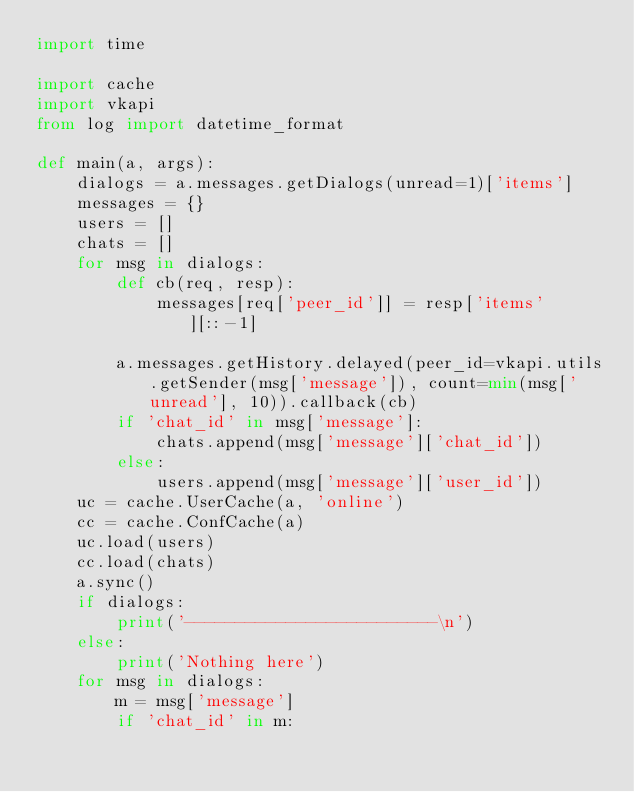<code> <loc_0><loc_0><loc_500><loc_500><_Python_>import time

import cache
import vkapi
from log import datetime_format

def main(a, args):
    dialogs = a.messages.getDialogs(unread=1)['items']
    messages = {}
    users = []
    chats = []
    for msg in dialogs:
        def cb(req, resp):
            messages[req['peer_id']] = resp['items'][::-1]

        a.messages.getHistory.delayed(peer_id=vkapi.utils.getSender(msg['message']), count=min(msg['unread'], 10)).callback(cb)
        if 'chat_id' in msg['message']:
            chats.append(msg['message']['chat_id'])
        else:
            users.append(msg['message']['user_id'])
    uc = cache.UserCache(a, 'online')
    cc = cache.ConfCache(a)
    uc.load(users)
    cc.load(chats)
    a.sync()
    if dialogs:
        print('-------------------------\n')
    else:
        print('Nothing here')
    for msg in dialogs:
        m = msg['message']
        if 'chat_id' in m:</code> 